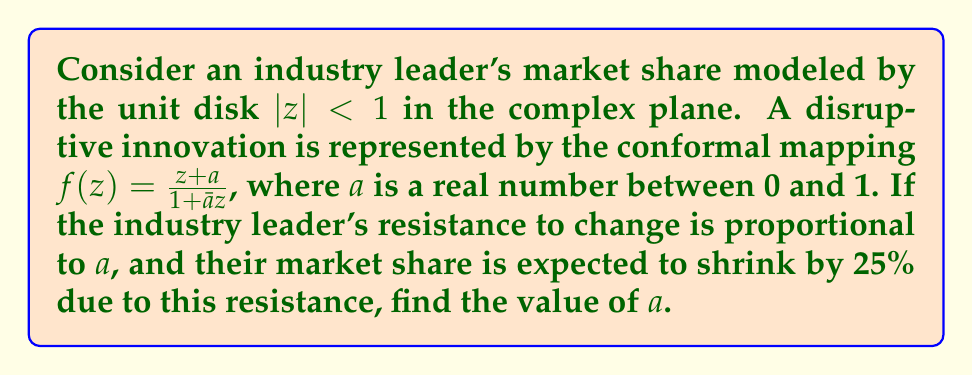Could you help me with this problem? To solve this problem, we need to understand how the conformal mapping $f(z) = \frac{z+a}{1+\bar{a}z}$ affects the unit disk:

1) This mapping is known as a Möbius transformation, which maps the unit disk to itself.

2) The point $z=-a$ is mapped to the origin: $f(-a) = \frac{-a+a}{1-a^2} = 0$

3) The origin is mapped to $a$: $f(0) = a$

4) The real axis is invariant under this transformation.

5) The area of the image of the unit disk under this mapping remains the same as the original disk (conformal mappings preserve local angles and shapes).

Now, let's consider the effect on the industry leader's market share:

6) The industry leader's original market share is represented by the entire unit disk, with an area of $\pi$.

7) After the disruption, their market share is represented by the region $|w| < r$ in the $w$-plane, where $w = f(z)$.

8) We're told that the market share shrinks by 25%, so the new area should be $0.75\pi$.

9) The area of the region $|w| < r$ is $\pi r^2$, so we need:

   $\pi r^2 = 0.75\pi$
   $r^2 = 0.75$
   $r = \sqrt{0.75} \approx 0.866$

10) In the $w$-plane, the point $a$ on the positive real axis should be at distance $r$ from the origin.

11) Therefore, $a = r = \sqrt{0.75} \approx 0.866$

This value of $a$ represents the industry leader's resistance to change, which results in a 25% reduction in market share.
Answer: $a = \sqrt{0.75} \approx 0.866$ 